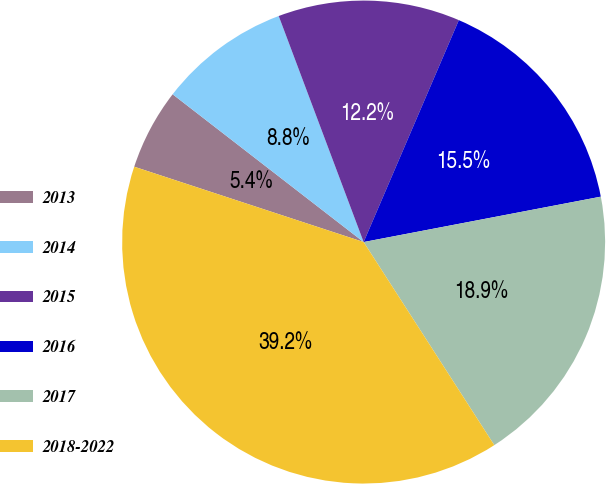Convert chart. <chart><loc_0><loc_0><loc_500><loc_500><pie_chart><fcel>2013<fcel>2014<fcel>2015<fcel>2016<fcel>2017<fcel>2018-2022<nl><fcel>5.43%<fcel>8.8%<fcel>12.17%<fcel>15.54%<fcel>18.91%<fcel>39.15%<nl></chart> 